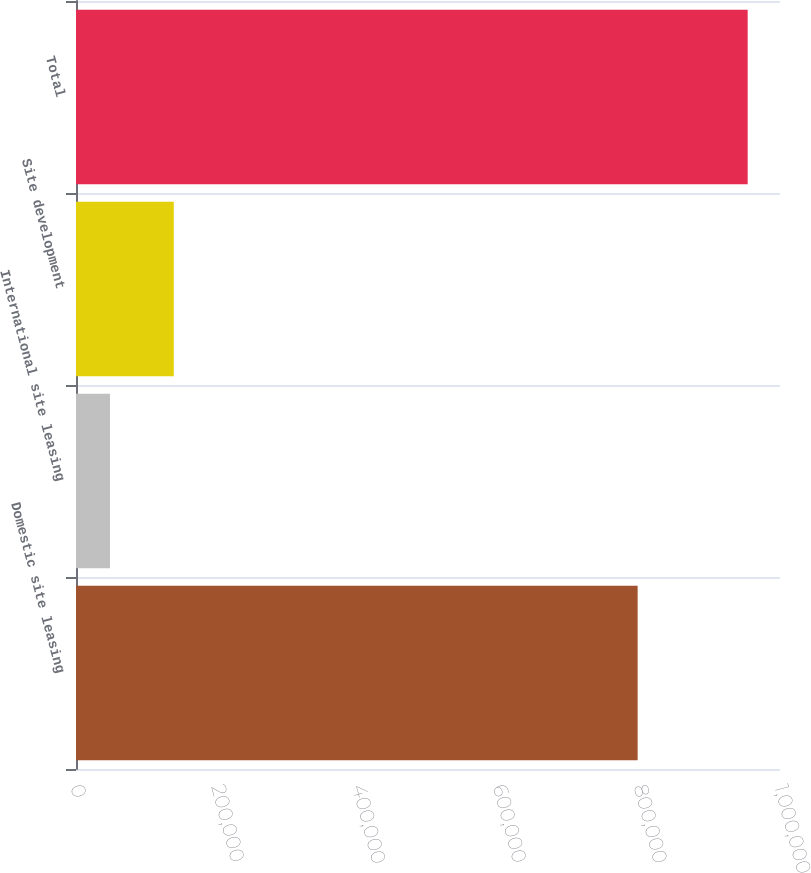<chart> <loc_0><loc_0><loc_500><loc_500><bar_chart><fcel>Domestic site leasing<fcel>International site leasing<fcel>Site development<fcel>Total<nl><fcel>797794<fcel>48300<fcel>138878<fcel>954084<nl></chart> 